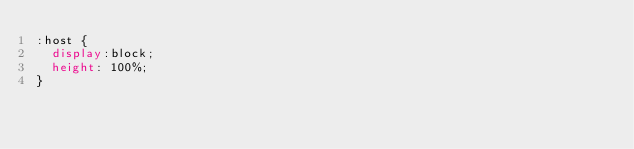Convert code to text. <code><loc_0><loc_0><loc_500><loc_500><_CSS_>:host {
  display:block;
  height: 100%;
}
</code> 